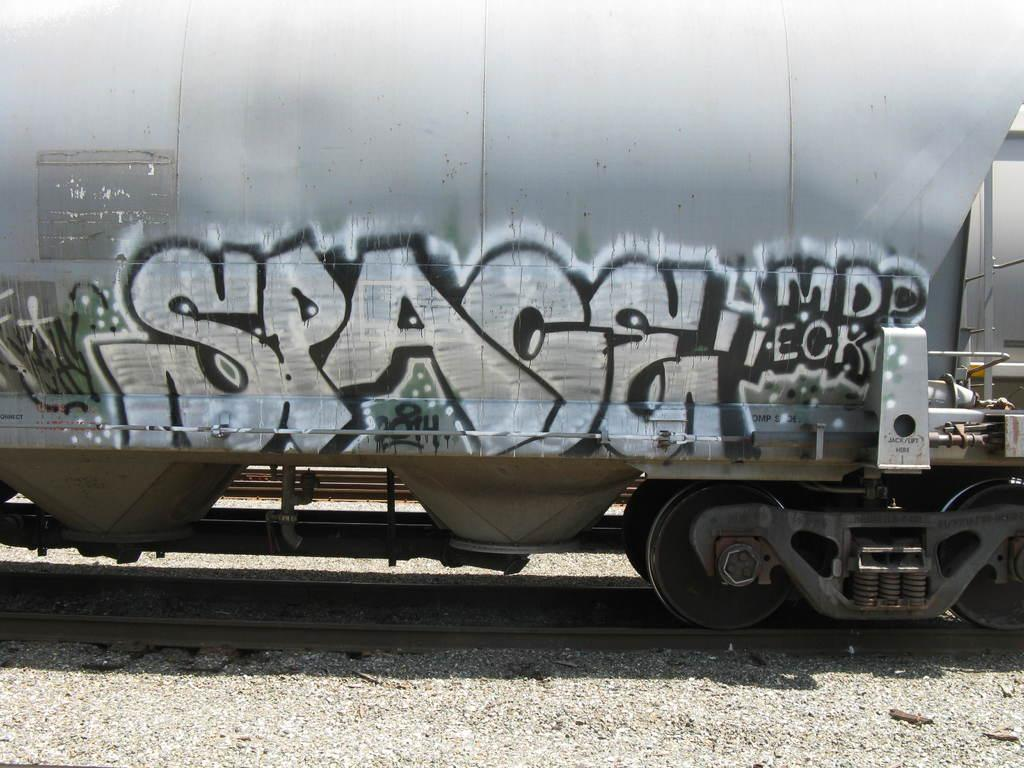What is depicted on the train in the image? There is graffiti on a train in the image. Where is the train located in the image? The train is on railway tracks in the image. What is the price of the oil used to create the graffiti on the train? There is no information about the price of oil or the creation process of the graffiti in the image. 